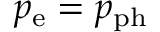<formula> <loc_0><loc_0><loc_500><loc_500>p _ { e } = p _ { p h }</formula> 